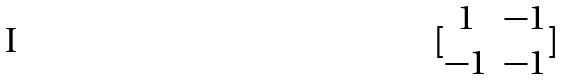<formula> <loc_0><loc_0><loc_500><loc_500>[ \begin{matrix} 1 & - 1 \\ - 1 & - 1 \end{matrix} ]</formula> 